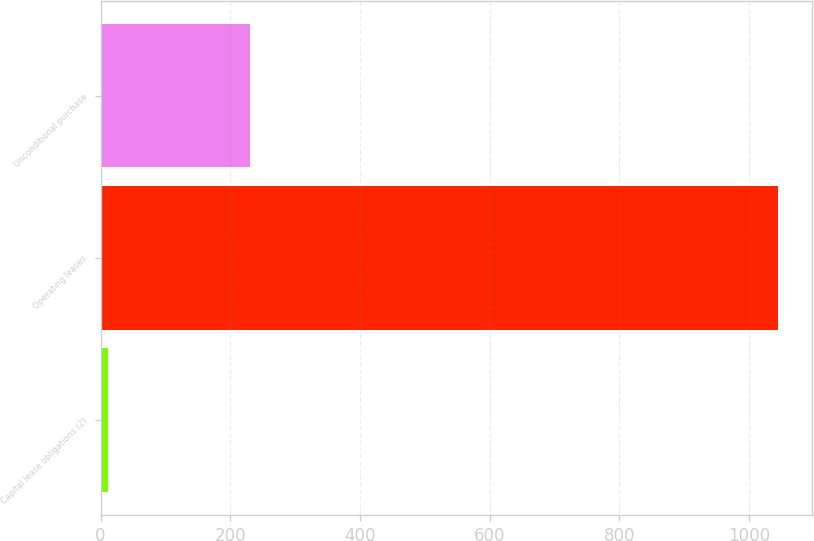Convert chart to OTSL. <chart><loc_0><loc_0><loc_500><loc_500><bar_chart><fcel>Capital lease obligations (2)<fcel>Operating leases<fcel>Unconditional purchase<nl><fcel>11<fcel>1045<fcel>231<nl></chart> 